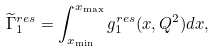<formula> <loc_0><loc_0><loc_500><loc_500>\widetilde { \Gamma } _ { 1 } ^ { r e s } = \int _ { x _ { \min } } ^ { x _ { \max } } g _ { 1 } ^ { r e s } ( x , Q ^ { 2 } ) d x ,</formula> 